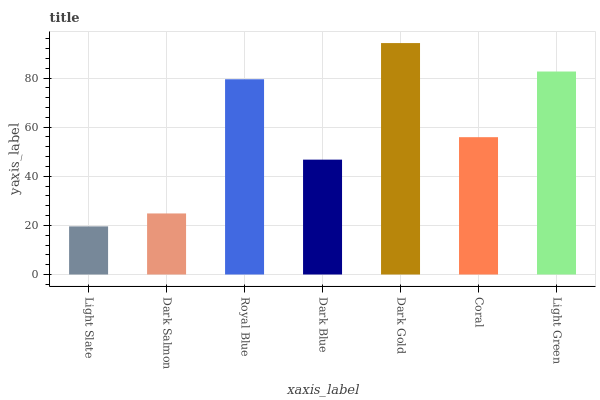Is Light Slate the minimum?
Answer yes or no. Yes. Is Dark Gold the maximum?
Answer yes or no. Yes. Is Dark Salmon the minimum?
Answer yes or no. No. Is Dark Salmon the maximum?
Answer yes or no. No. Is Dark Salmon greater than Light Slate?
Answer yes or no. Yes. Is Light Slate less than Dark Salmon?
Answer yes or no. Yes. Is Light Slate greater than Dark Salmon?
Answer yes or no. No. Is Dark Salmon less than Light Slate?
Answer yes or no. No. Is Coral the high median?
Answer yes or no. Yes. Is Coral the low median?
Answer yes or no. Yes. Is Royal Blue the high median?
Answer yes or no. No. Is Light Slate the low median?
Answer yes or no. No. 